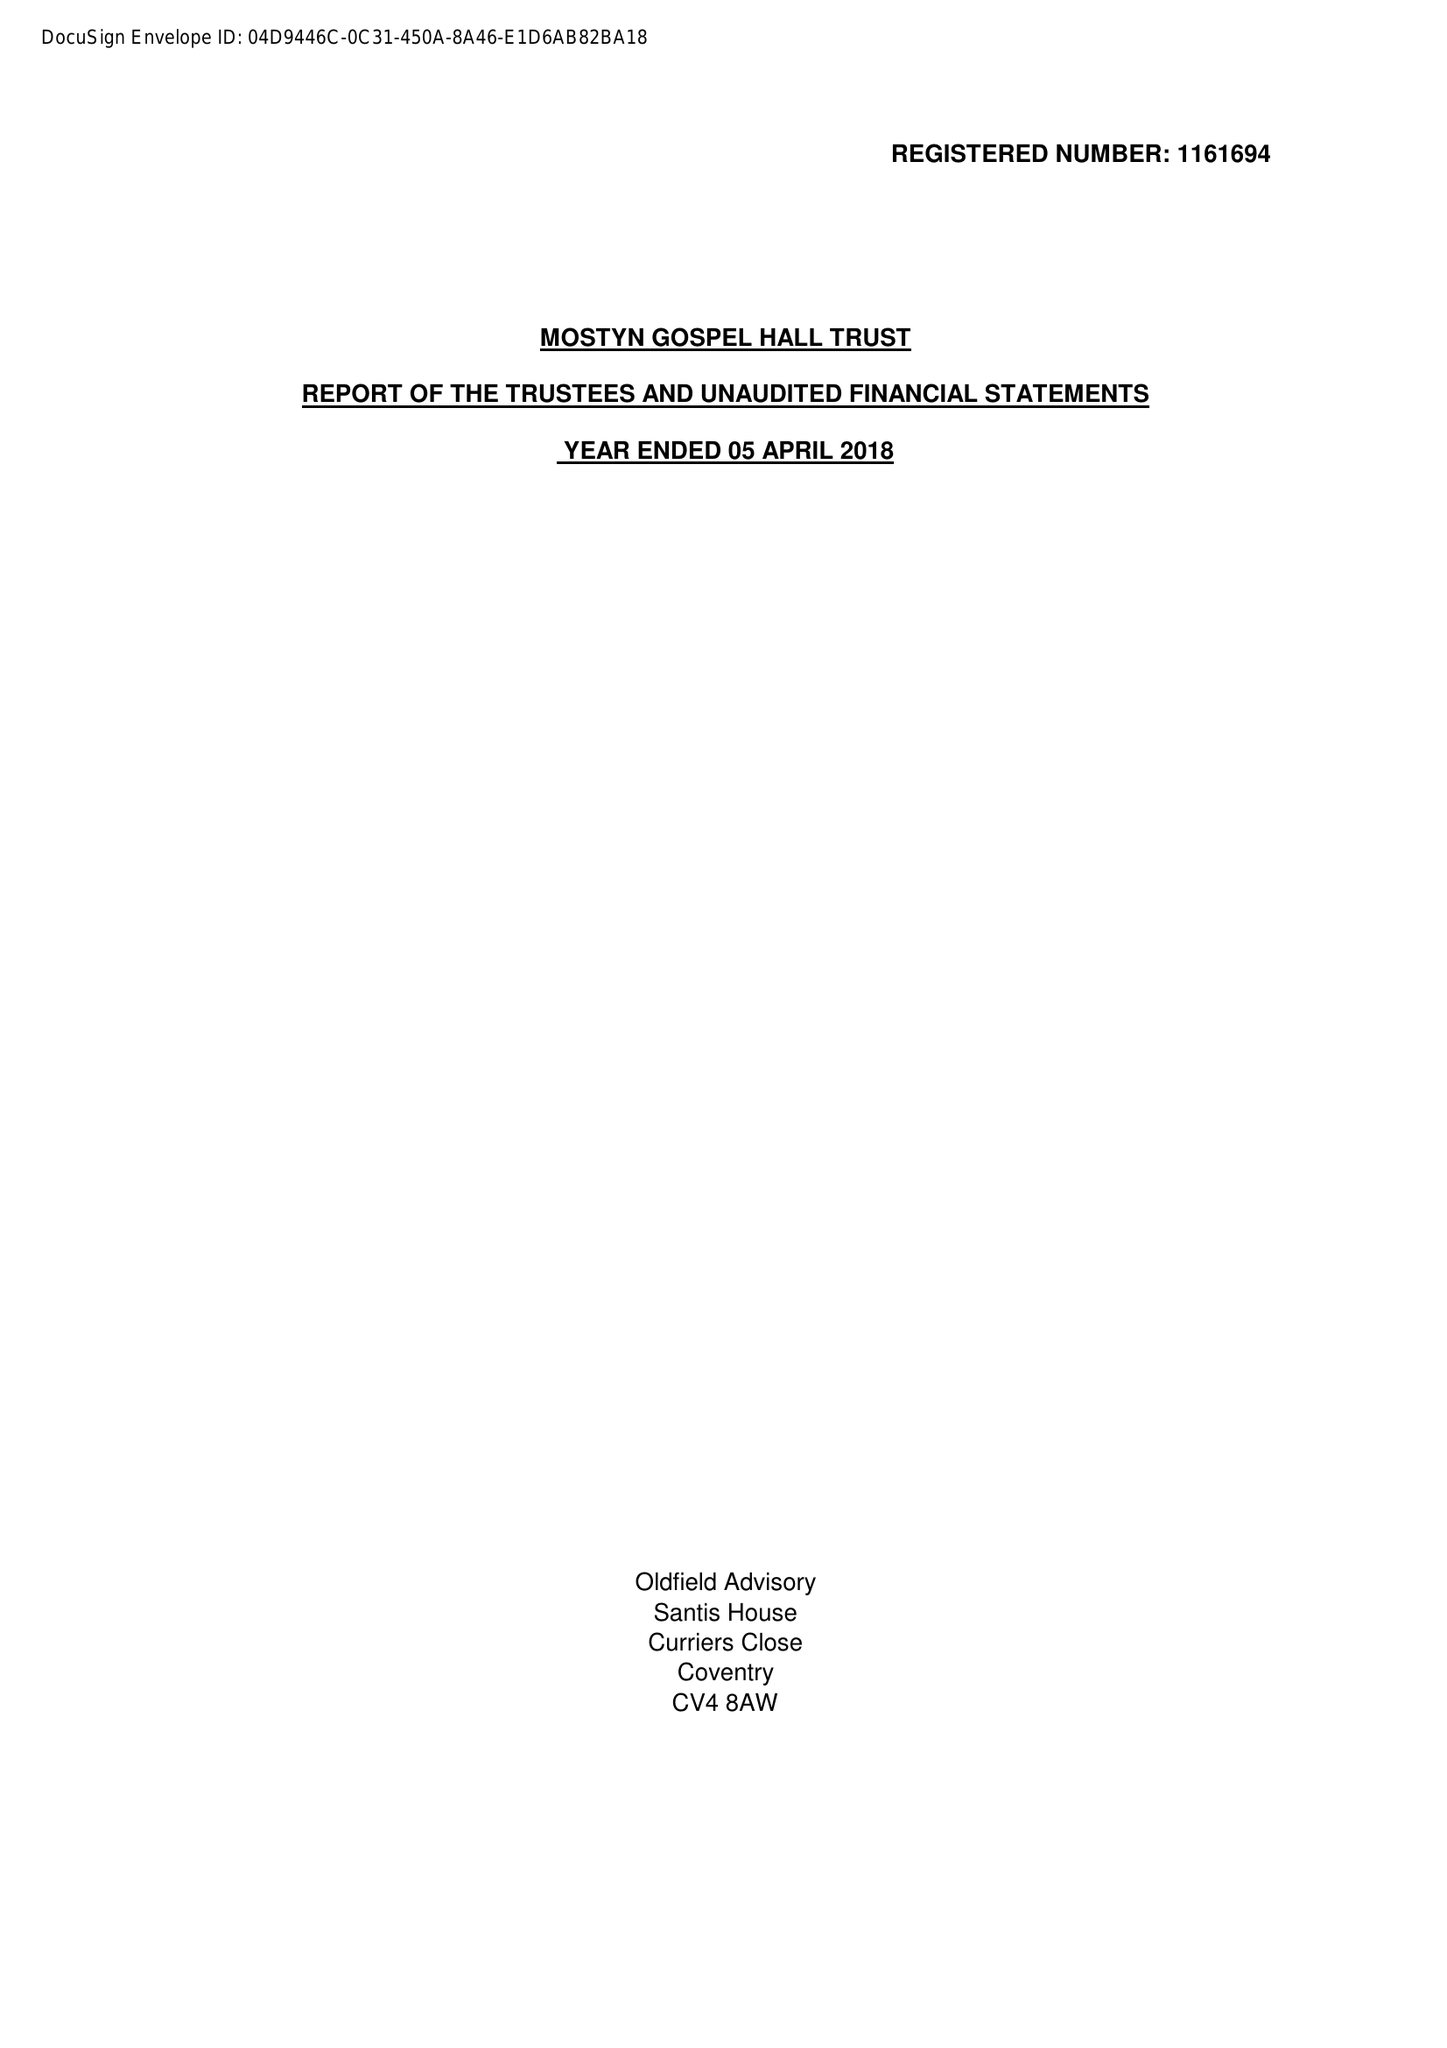What is the value for the report_date?
Answer the question using a single word or phrase. 2018-04-05 